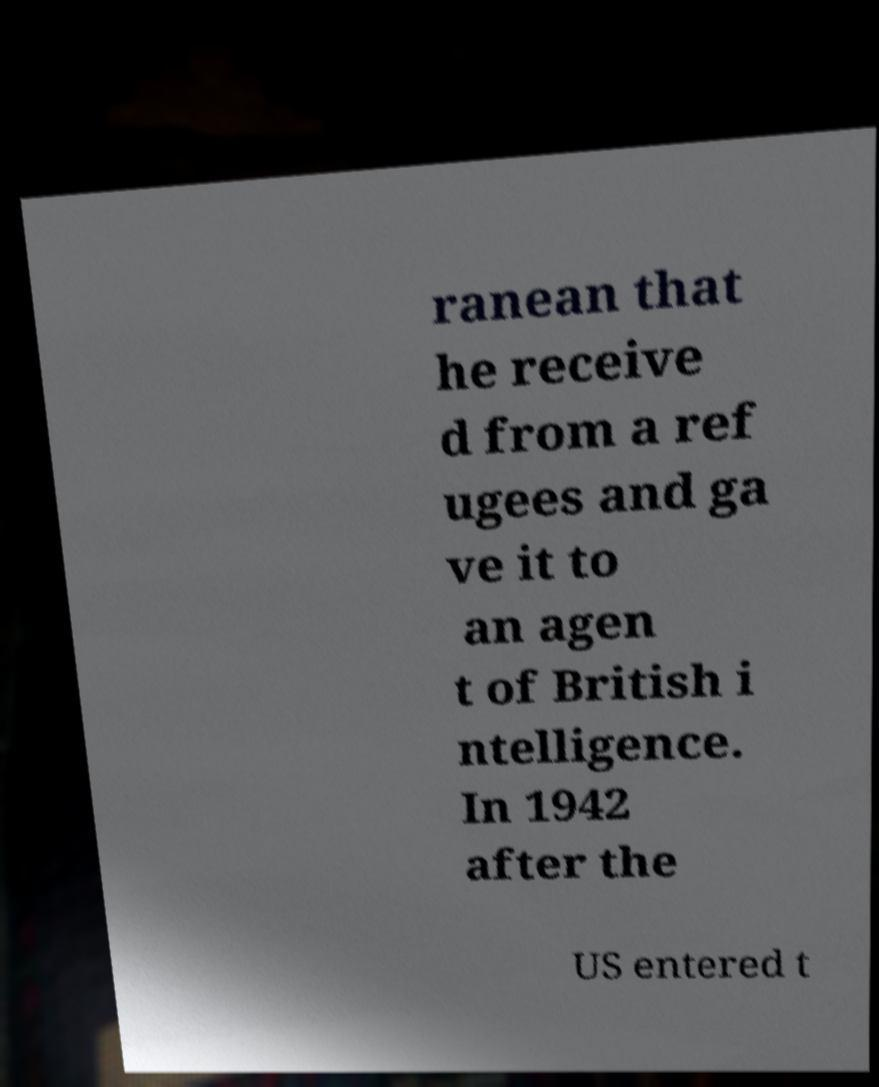There's text embedded in this image that I need extracted. Can you transcribe it verbatim? ranean that he receive d from a ref ugees and ga ve it to an agen t of British i ntelligence. In 1942 after the US entered t 